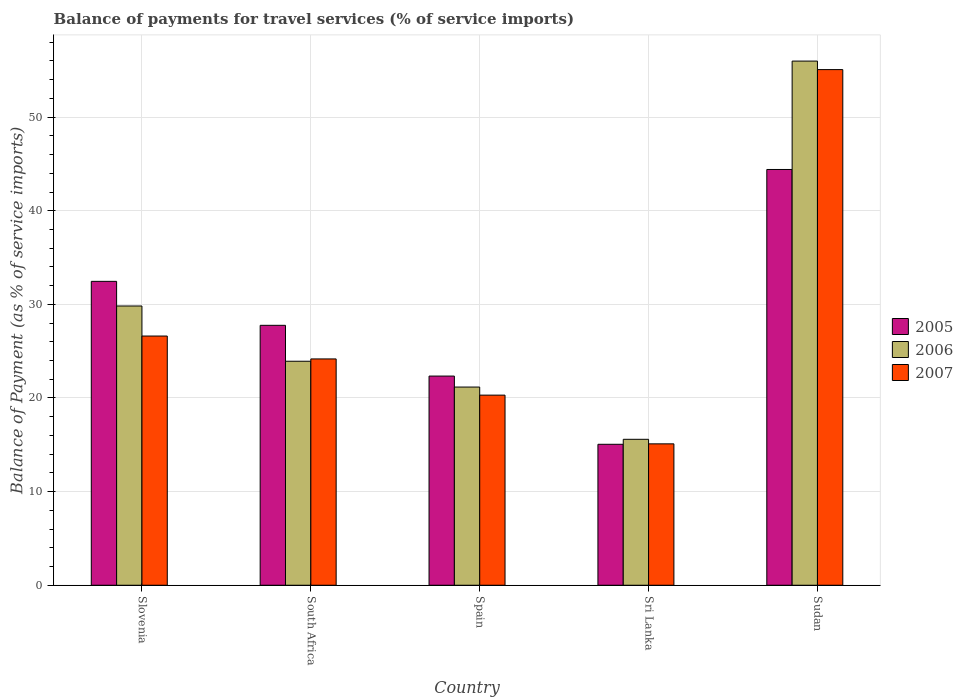Are the number of bars per tick equal to the number of legend labels?
Your response must be concise. Yes. How many bars are there on the 2nd tick from the left?
Keep it short and to the point. 3. How many bars are there on the 3rd tick from the right?
Give a very brief answer. 3. What is the label of the 5th group of bars from the left?
Ensure brevity in your answer.  Sudan. In how many cases, is the number of bars for a given country not equal to the number of legend labels?
Your answer should be very brief. 0. What is the balance of payments for travel services in 2006 in Sri Lanka?
Offer a terse response. 15.59. Across all countries, what is the maximum balance of payments for travel services in 2006?
Offer a terse response. 55.99. Across all countries, what is the minimum balance of payments for travel services in 2006?
Give a very brief answer. 15.59. In which country was the balance of payments for travel services in 2005 maximum?
Your answer should be compact. Sudan. In which country was the balance of payments for travel services in 2005 minimum?
Keep it short and to the point. Sri Lanka. What is the total balance of payments for travel services in 2007 in the graph?
Your answer should be compact. 141.28. What is the difference between the balance of payments for travel services in 2007 in South Africa and that in Sri Lanka?
Your response must be concise. 9.07. What is the difference between the balance of payments for travel services in 2007 in Spain and the balance of payments for travel services in 2005 in Sudan?
Your answer should be compact. -24.1. What is the average balance of payments for travel services in 2006 per country?
Keep it short and to the point. 29.3. What is the difference between the balance of payments for travel services of/in 2007 and balance of payments for travel services of/in 2006 in Sri Lanka?
Make the answer very short. -0.49. What is the ratio of the balance of payments for travel services in 2005 in Spain to that in Sudan?
Your answer should be compact. 0.5. Is the balance of payments for travel services in 2007 in Sri Lanka less than that in Sudan?
Provide a short and direct response. Yes. What is the difference between the highest and the second highest balance of payments for travel services in 2007?
Your answer should be compact. -2.45. What is the difference between the highest and the lowest balance of payments for travel services in 2006?
Your answer should be compact. 40.4. In how many countries, is the balance of payments for travel services in 2007 greater than the average balance of payments for travel services in 2007 taken over all countries?
Ensure brevity in your answer.  1. Is the sum of the balance of payments for travel services in 2006 in Slovenia and Sudan greater than the maximum balance of payments for travel services in 2005 across all countries?
Give a very brief answer. Yes. What does the 3rd bar from the left in Sudan represents?
Offer a very short reply. 2007. What does the 3rd bar from the right in Slovenia represents?
Offer a very short reply. 2005. Is it the case that in every country, the sum of the balance of payments for travel services in 2007 and balance of payments for travel services in 2005 is greater than the balance of payments for travel services in 2006?
Offer a very short reply. Yes. What is the difference between two consecutive major ticks on the Y-axis?
Your answer should be very brief. 10. Does the graph contain any zero values?
Provide a short and direct response. No. Does the graph contain grids?
Offer a very short reply. Yes. Where does the legend appear in the graph?
Your answer should be very brief. Center right. What is the title of the graph?
Give a very brief answer. Balance of payments for travel services (% of service imports). What is the label or title of the X-axis?
Make the answer very short. Country. What is the label or title of the Y-axis?
Offer a terse response. Balance of Payment (as % of service imports). What is the Balance of Payment (as % of service imports) in 2005 in Slovenia?
Ensure brevity in your answer.  32.46. What is the Balance of Payment (as % of service imports) of 2006 in Slovenia?
Provide a short and direct response. 29.83. What is the Balance of Payment (as % of service imports) of 2007 in Slovenia?
Make the answer very short. 26.62. What is the Balance of Payment (as % of service imports) of 2005 in South Africa?
Make the answer very short. 27.76. What is the Balance of Payment (as % of service imports) of 2006 in South Africa?
Offer a very short reply. 23.93. What is the Balance of Payment (as % of service imports) of 2007 in South Africa?
Offer a terse response. 24.17. What is the Balance of Payment (as % of service imports) of 2005 in Spain?
Your answer should be compact. 22.34. What is the Balance of Payment (as % of service imports) of 2006 in Spain?
Keep it short and to the point. 21.17. What is the Balance of Payment (as % of service imports) in 2007 in Spain?
Your answer should be very brief. 20.31. What is the Balance of Payment (as % of service imports) of 2005 in Sri Lanka?
Your answer should be compact. 15.06. What is the Balance of Payment (as % of service imports) in 2006 in Sri Lanka?
Your answer should be very brief. 15.59. What is the Balance of Payment (as % of service imports) of 2007 in Sri Lanka?
Make the answer very short. 15.1. What is the Balance of Payment (as % of service imports) in 2005 in Sudan?
Provide a short and direct response. 44.41. What is the Balance of Payment (as % of service imports) of 2006 in Sudan?
Provide a succinct answer. 55.99. What is the Balance of Payment (as % of service imports) in 2007 in Sudan?
Offer a very short reply. 55.08. Across all countries, what is the maximum Balance of Payment (as % of service imports) in 2005?
Provide a short and direct response. 44.41. Across all countries, what is the maximum Balance of Payment (as % of service imports) of 2006?
Provide a short and direct response. 55.99. Across all countries, what is the maximum Balance of Payment (as % of service imports) in 2007?
Offer a terse response. 55.08. Across all countries, what is the minimum Balance of Payment (as % of service imports) in 2005?
Your response must be concise. 15.06. Across all countries, what is the minimum Balance of Payment (as % of service imports) of 2006?
Your response must be concise. 15.59. Across all countries, what is the minimum Balance of Payment (as % of service imports) in 2007?
Provide a short and direct response. 15.1. What is the total Balance of Payment (as % of service imports) in 2005 in the graph?
Your response must be concise. 142.03. What is the total Balance of Payment (as % of service imports) in 2006 in the graph?
Your answer should be compact. 146.5. What is the total Balance of Payment (as % of service imports) of 2007 in the graph?
Provide a short and direct response. 141.28. What is the difference between the Balance of Payment (as % of service imports) in 2005 in Slovenia and that in South Africa?
Keep it short and to the point. 4.7. What is the difference between the Balance of Payment (as % of service imports) in 2006 in Slovenia and that in South Africa?
Offer a very short reply. 5.9. What is the difference between the Balance of Payment (as % of service imports) of 2007 in Slovenia and that in South Africa?
Your answer should be very brief. 2.45. What is the difference between the Balance of Payment (as % of service imports) of 2005 in Slovenia and that in Spain?
Offer a very short reply. 10.12. What is the difference between the Balance of Payment (as % of service imports) of 2006 in Slovenia and that in Spain?
Offer a very short reply. 8.66. What is the difference between the Balance of Payment (as % of service imports) in 2007 in Slovenia and that in Spain?
Ensure brevity in your answer.  6.31. What is the difference between the Balance of Payment (as % of service imports) in 2005 in Slovenia and that in Sri Lanka?
Provide a short and direct response. 17.41. What is the difference between the Balance of Payment (as % of service imports) of 2006 in Slovenia and that in Sri Lanka?
Your answer should be compact. 14.24. What is the difference between the Balance of Payment (as % of service imports) in 2007 in Slovenia and that in Sri Lanka?
Provide a short and direct response. 11.52. What is the difference between the Balance of Payment (as % of service imports) of 2005 in Slovenia and that in Sudan?
Keep it short and to the point. -11.95. What is the difference between the Balance of Payment (as % of service imports) of 2006 in Slovenia and that in Sudan?
Your answer should be compact. -26.16. What is the difference between the Balance of Payment (as % of service imports) of 2007 in Slovenia and that in Sudan?
Give a very brief answer. -28.46. What is the difference between the Balance of Payment (as % of service imports) of 2005 in South Africa and that in Spain?
Provide a succinct answer. 5.42. What is the difference between the Balance of Payment (as % of service imports) of 2006 in South Africa and that in Spain?
Offer a terse response. 2.76. What is the difference between the Balance of Payment (as % of service imports) of 2007 in South Africa and that in Spain?
Offer a very short reply. 3.87. What is the difference between the Balance of Payment (as % of service imports) in 2005 in South Africa and that in Sri Lanka?
Offer a terse response. 12.71. What is the difference between the Balance of Payment (as % of service imports) of 2006 in South Africa and that in Sri Lanka?
Provide a short and direct response. 8.34. What is the difference between the Balance of Payment (as % of service imports) of 2007 in South Africa and that in Sri Lanka?
Your response must be concise. 9.07. What is the difference between the Balance of Payment (as % of service imports) in 2005 in South Africa and that in Sudan?
Your answer should be compact. -16.65. What is the difference between the Balance of Payment (as % of service imports) of 2006 in South Africa and that in Sudan?
Offer a terse response. -32.06. What is the difference between the Balance of Payment (as % of service imports) in 2007 in South Africa and that in Sudan?
Give a very brief answer. -30.91. What is the difference between the Balance of Payment (as % of service imports) of 2005 in Spain and that in Sri Lanka?
Offer a terse response. 7.29. What is the difference between the Balance of Payment (as % of service imports) in 2006 in Spain and that in Sri Lanka?
Offer a very short reply. 5.58. What is the difference between the Balance of Payment (as % of service imports) in 2007 in Spain and that in Sri Lanka?
Your answer should be very brief. 5.21. What is the difference between the Balance of Payment (as % of service imports) in 2005 in Spain and that in Sudan?
Make the answer very short. -22.07. What is the difference between the Balance of Payment (as % of service imports) in 2006 in Spain and that in Sudan?
Provide a succinct answer. -34.82. What is the difference between the Balance of Payment (as % of service imports) in 2007 in Spain and that in Sudan?
Make the answer very short. -34.77. What is the difference between the Balance of Payment (as % of service imports) of 2005 in Sri Lanka and that in Sudan?
Your answer should be compact. -29.35. What is the difference between the Balance of Payment (as % of service imports) of 2006 in Sri Lanka and that in Sudan?
Provide a succinct answer. -40.4. What is the difference between the Balance of Payment (as % of service imports) in 2007 in Sri Lanka and that in Sudan?
Keep it short and to the point. -39.98. What is the difference between the Balance of Payment (as % of service imports) of 2005 in Slovenia and the Balance of Payment (as % of service imports) of 2006 in South Africa?
Your answer should be very brief. 8.53. What is the difference between the Balance of Payment (as % of service imports) in 2005 in Slovenia and the Balance of Payment (as % of service imports) in 2007 in South Africa?
Your answer should be compact. 8.29. What is the difference between the Balance of Payment (as % of service imports) of 2006 in Slovenia and the Balance of Payment (as % of service imports) of 2007 in South Africa?
Offer a very short reply. 5.66. What is the difference between the Balance of Payment (as % of service imports) in 2005 in Slovenia and the Balance of Payment (as % of service imports) in 2006 in Spain?
Provide a short and direct response. 11.29. What is the difference between the Balance of Payment (as % of service imports) of 2005 in Slovenia and the Balance of Payment (as % of service imports) of 2007 in Spain?
Keep it short and to the point. 12.15. What is the difference between the Balance of Payment (as % of service imports) of 2006 in Slovenia and the Balance of Payment (as % of service imports) of 2007 in Spain?
Offer a terse response. 9.52. What is the difference between the Balance of Payment (as % of service imports) in 2005 in Slovenia and the Balance of Payment (as % of service imports) in 2006 in Sri Lanka?
Offer a very short reply. 16.87. What is the difference between the Balance of Payment (as % of service imports) in 2005 in Slovenia and the Balance of Payment (as % of service imports) in 2007 in Sri Lanka?
Make the answer very short. 17.36. What is the difference between the Balance of Payment (as % of service imports) in 2006 in Slovenia and the Balance of Payment (as % of service imports) in 2007 in Sri Lanka?
Your answer should be very brief. 14.73. What is the difference between the Balance of Payment (as % of service imports) of 2005 in Slovenia and the Balance of Payment (as % of service imports) of 2006 in Sudan?
Provide a short and direct response. -23.53. What is the difference between the Balance of Payment (as % of service imports) of 2005 in Slovenia and the Balance of Payment (as % of service imports) of 2007 in Sudan?
Your answer should be very brief. -22.62. What is the difference between the Balance of Payment (as % of service imports) in 2006 in Slovenia and the Balance of Payment (as % of service imports) in 2007 in Sudan?
Your answer should be very brief. -25.25. What is the difference between the Balance of Payment (as % of service imports) in 2005 in South Africa and the Balance of Payment (as % of service imports) in 2006 in Spain?
Give a very brief answer. 6.59. What is the difference between the Balance of Payment (as % of service imports) in 2005 in South Africa and the Balance of Payment (as % of service imports) in 2007 in Spain?
Keep it short and to the point. 7.46. What is the difference between the Balance of Payment (as % of service imports) of 2006 in South Africa and the Balance of Payment (as % of service imports) of 2007 in Spain?
Provide a short and direct response. 3.62. What is the difference between the Balance of Payment (as % of service imports) in 2005 in South Africa and the Balance of Payment (as % of service imports) in 2006 in Sri Lanka?
Offer a very short reply. 12.18. What is the difference between the Balance of Payment (as % of service imports) of 2005 in South Africa and the Balance of Payment (as % of service imports) of 2007 in Sri Lanka?
Keep it short and to the point. 12.66. What is the difference between the Balance of Payment (as % of service imports) of 2006 in South Africa and the Balance of Payment (as % of service imports) of 2007 in Sri Lanka?
Your answer should be compact. 8.82. What is the difference between the Balance of Payment (as % of service imports) of 2005 in South Africa and the Balance of Payment (as % of service imports) of 2006 in Sudan?
Ensure brevity in your answer.  -28.22. What is the difference between the Balance of Payment (as % of service imports) of 2005 in South Africa and the Balance of Payment (as % of service imports) of 2007 in Sudan?
Your answer should be very brief. -27.31. What is the difference between the Balance of Payment (as % of service imports) in 2006 in South Africa and the Balance of Payment (as % of service imports) in 2007 in Sudan?
Your answer should be compact. -31.15. What is the difference between the Balance of Payment (as % of service imports) in 2005 in Spain and the Balance of Payment (as % of service imports) in 2006 in Sri Lanka?
Provide a succinct answer. 6.75. What is the difference between the Balance of Payment (as % of service imports) of 2005 in Spain and the Balance of Payment (as % of service imports) of 2007 in Sri Lanka?
Ensure brevity in your answer.  7.24. What is the difference between the Balance of Payment (as % of service imports) in 2006 in Spain and the Balance of Payment (as % of service imports) in 2007 in Sri Lanka?
Offer a very short reply. 6.07. What is the difference between the Balance of Payment (as % of service imports) in 2005 in Spain and the Balance of Payment (as % of service imports) in 2006 in Sudan?
Your answer should be very brief. -33.65. What is the difference between the Balance of Payment (as % of service imports) of 2005 in Spain and the Balance of Payment (as % of service imports) of 2007 in Sudan?
Offer a terse response. -32.74. What is the difference between the Balance of Payment (as % of service imports) in 2006 in Spain and the Balance of Payment (as % of service imports) in 2007 in Sudan?
Give a very brief answer. -33.91. What is the difference between the Balance of Payment (as % of service imports) of 2005 in Sri Lanka and the Balance of Payment (as % of service imports) of 2006 in Sudan?
Your response must be concise. -40.93. What is the difference between the Balance of Payment (as % of service imports) of 2005 in Sri Lanka and the Balance of Payment (as % of service imports) of 2007 in Sudan?
Your response must be concise. -40.02. What is the difference between the Balance of Payment (as % of service imports) of 2006 in Sri Lanka and the Balance of Payment (as % of service imports) of 2007 in Sudan?
Make the answer very short. -39.49. What is the average Balance of Payment (as % of service imports) in 2005 per country?
Give a very brief answer. 28.41. What is the average Balance of Payment (as % of service imports) in 2006 per country?
Your answer should be compact. 29.3. What is the average Balance of Payment (as % of service imports) in 2007 per country?
Keep it short and to the point. 28.26. What is the difference between the Balance of Payment (as % of service imports) of 2005 and Balance of Payment (as % of service imports) of 2006 in Slovenia?
Your answer should be very brief. 2.63. What is the difference between the Balance of Payment (as % of service imports) of 2005 and Balance of Payment (as % of service imports) of 2007 in Slovenia?
Your response must be concise. 5.84. What is the difference between the Balance of Payment (as % of service imports) of 2006 and Balance of Payment (as % of service imports) of 2007 in Slovenia?
Your response must be concise. 3.21. What is the difference between the Balance of Payment (as % of service imports) of 2005 and Balance of Payment (as % of service imports) of 2006 in South Africa?
Your response must be concise. 3.84. What is the difference between the Balance of Payment (as % of service imports) of 2005 and Balance of Payment (as % of service imports) of 2007 in South Africa?
Your answer should be compact. 3.59. What is the difference between the Balance of Payment (as % of service imports) of 2006 and Balance of Payment (as % of service imports) of 2007 in South Africa?
Give a very brief answer. -0.25. What is the difference between the Balance of Payment (as % of service imports) in 2005 and Balance of Payment (as % of service imports) in 2006 in Spain?
Offer a very short reply. 1.17. What is the difference between the Balance of Payment (as % of service imports) in 2005 and Balance of Payment (as % of service imports) in 2007 in Spain?
Your answer should be very brief. 2.04. What is the difference between the Balance of Payment (as % of service imports) of 2006 and Balance of Payment (as % of service imports) of 2007 in Spain?
Offer a terse response. 0.86. What is the difference between the Balance of Payment (as % of service imports) in 2005 and Balance of Payment (as % of service imports) in 2006 in Sri Lanka?
Make the answer very short. -0.53. What is the difference between the Balance of Payment (as % of service imports) in 2005 and Balance of Payment (as % of service imports) in 2007 in Sri Lanka?
Your answer should be very brief. -0.05. What is the difference between the Balance of Payment (as % of service imports) in 2006 and Balance of Payment (as % of service imports) in 2007 in Sri Lanka?
Provide a short and direct response. 0.49. What is the difference between the Balance of Payment (as % of service imports) in 2005 and Balance of Payment (as % of service imports) in 2006 in Sudan?
Make the answer very short. -11.58. What is the difference between the Balance of Payment (as % of service imports) in 2005 and Balance of Payment (as % of service imports) in 2007 in Sudan?
Provide a short and direct response. -10.67. What is the difference between the Balance of Payment (as % of service imports) in 2006 and Balance of Payment (as % of service imports) in 2007 in Sudan?
Ensure brevity in your answer.  0.91. What is the ratio of the Balance of Payment (as % of service imports) of 2005 in Slovenia to that in South Africa?
Offer a terse response. 1.17. What is the ratio of the Balance of Payment (as % of service imports) of 2006 in Slovenia to that in South Africa?
Give a very brief answer. 1.25. What is the ratio of the Balance of Payment (as % of service imports) of 2007 in Slovenia to that in South Africa?
Your answer should be compact. 1.1. What is the ratio of the Balance of Payment (as % of service imports) in 2005 in Slovenia to that in Spain?
Make the answer very short. 1.45. What is the ratio of the Balance of Payment (as % of service imports) in 2006 in Slovenia to that in Spain?
Your response must be concise. 1.41. What is the ratio of the Balance of Payment (as % of service imports) in 2007 in Slovenia to that in Spain?
Provide a succinct answer. 1.31. What is the ratio of the Balance of Payment (as % of service imports) in 2005 in Slovenia to that in Sri Lanka?
Keep it short and to the point. 2.16. What is the ratio of the Balance of Payment (as % of service imports) in 2006 in Slovenia to that in Sri Lanka?
Offer a very short reply. 1.91. What is the ratio of the Balance of Payment (as % of service imports) in 2007 in Slovenia to that in Sri Lanka?
Offer a very short reply. 1.76. What is the ratio of the Balance of Payment (as % of service imports) in 2005 in Slovenia to that in Sudan?
Make the answer very short. 0.73. What is the ratio of the Balance of Payment (as % of service imports) in 2006 in Slovenia to that in Sudan?
Offer a very short reply. 0.53. What is the ratio of the Balance of Payment (as % of service imports) of 2007 in Slovenia to that in Sudan?
Provide a short and direct response. 0.48. What is the ratio of the Balance of Payment (as % of service imports) in 2005 in South Africa to that in Spain?
Your answer should be compact. 1.24. What is the ratio of the Balance of Payment (as % of service imports) of 2006 in South Africa to that in Spain?
Provide a succinct answer. 1.13. What is the ratio of the Balance of Payment (as % of service imports) in 2007 in South Africa to that in Spain?
Your response must be concise. 1.19. What is the ratio of the Balance of Payment (as % of service imports) of 2005 in South Africa to that in Sri Lanka?
Keep it short and to the point. 1.84. What is the ratio of the Balance of Payment (as % of service imports) in 2006 in South Africa to that in Sri Lanka?
Make the answer very short. 1.53. What is the ratio of the Balance of Payment (as % of service imports) of 2007 in South Africa to that in Sri Lanka?
Your response must be concise. 1.6. What is the ratio of the Balance of Payment (as % of service imports) of 2005 in South Africa to that in Sudan?
Your answer should be very brief. 0.63. What is the ratio of the Balance of Payment (as % of service imports) of 2006 in South Africa to that in Sudan?
Provide a short and direct response. 0.43. What is the ratio of the Balance of Payment (as % of service imports) of 2007 in South Africa to that in Sudan?
Provide a succinct answer. 0.44. What is the ratio of the Balance of Payment (as % of service imports) of 2005 in Spain to that in Sri Lanka?
Keep it short and to the point. 1.48. What is the ratio of the Balance of Payment (as % of service imports) of 2006 in Spain to that in Sri Lanka?
Ensure brevity in your answer.  1.36. What is the ratio of the Balance of Payment (as % of service imports) of 2007 in Spain to that in Sri Lanka?
Keep it short and to the point. 1.34. What is the ratio of the Balance of Payment (as % of service imports) in 2005 in Spain to that in Sudan?
Offer a terse response. 0.5. What is the ratio of the Balance of Payment (as % of service imports) in 2006 in Spain to that in Sudan?
Offer a terse response. 0.38. What is the ratio of the Balance of Payment (as % of service imports) of 2007 in Spain to that in Sudan?
Provide a succinct answer. 0.37. What is the ratio of the Balance of Payment (as % of service imports) of 2005 in Sri Lanka to that in Sudan?
Your answer should be very brief. 0.34. What is the ratio of the Balance of Payment (as % of service imports) of 2006 in Sri Lanka to that in Sudan?
Give a very brief answer. 0.28. What is the ratio of the Balance of Payment (as % of service imports) of 2007 in Sri Lanka to that in Sudan?
Ensure brevity in your answer.  0.27. What is the difference between the highest and the second highest Balance of Payment (as % of service imports) of 2005?
Make the answer very short. 11.95. What is the difference between the highest and the second highest Balance of Payment (as % of service imports) in 2006?
Provide a succinct answer. 26.16. What is the difference between the highest and the second highest Balance of Payment (as % of service imports) in 2007?
Make the answer very short. 28.46. What is the difference between the highest and the lowest Balance of Payment (as % of service imports) in 2005?
Keep it short and to the point. 29.35. What is the difference between the highest and the lowest Balance of Payment (as % of service imports) in 2006?
Your answer should be very brief. 40.4. What is the difference between the highest and the lowest Balance of Payment (as % of service imports) in 2007?
Give a very brief answer. 39.98. 